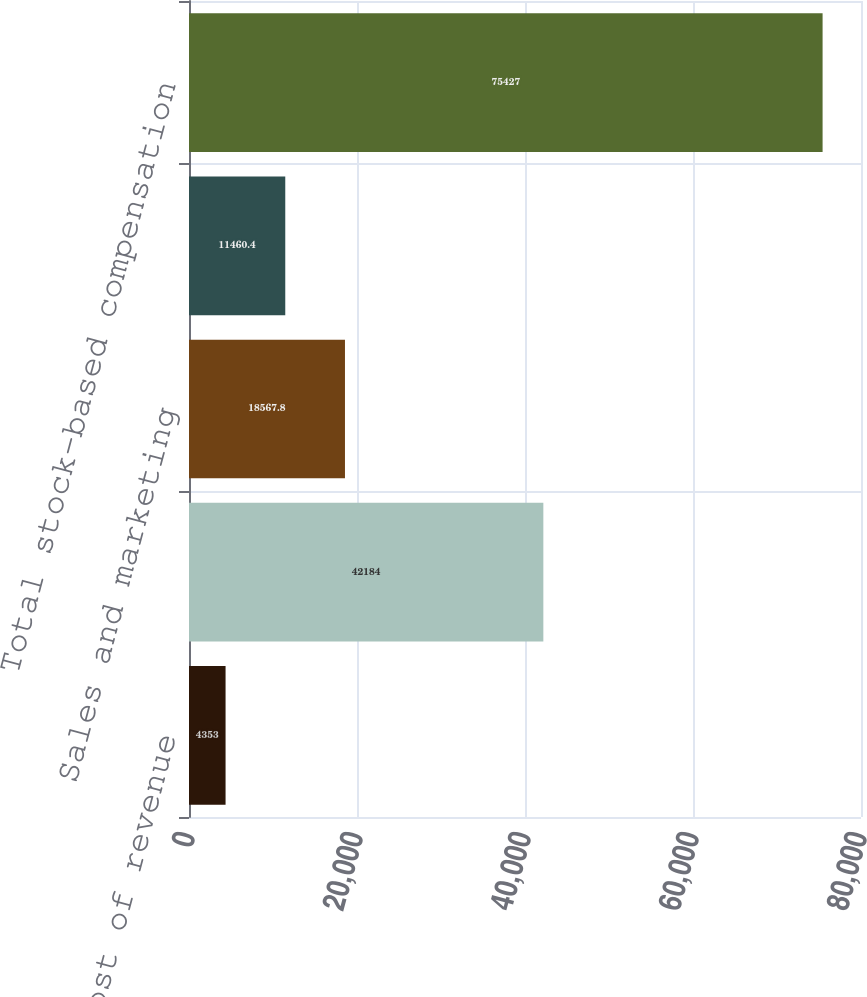Convert chart to OTSL. <chart><loc_0><loc_0><loc_500><loc_500><bar_chart><fcel>Cost of revenue<fcel>Research and development<fcel>Sales and marketing<fcel>General and administrative<fcel>Total stock-based compensation<nl><fcel>4353<fcel>42184<fcel>18567.8<fcel>11460.4<fcel>75427<nl></chart> 